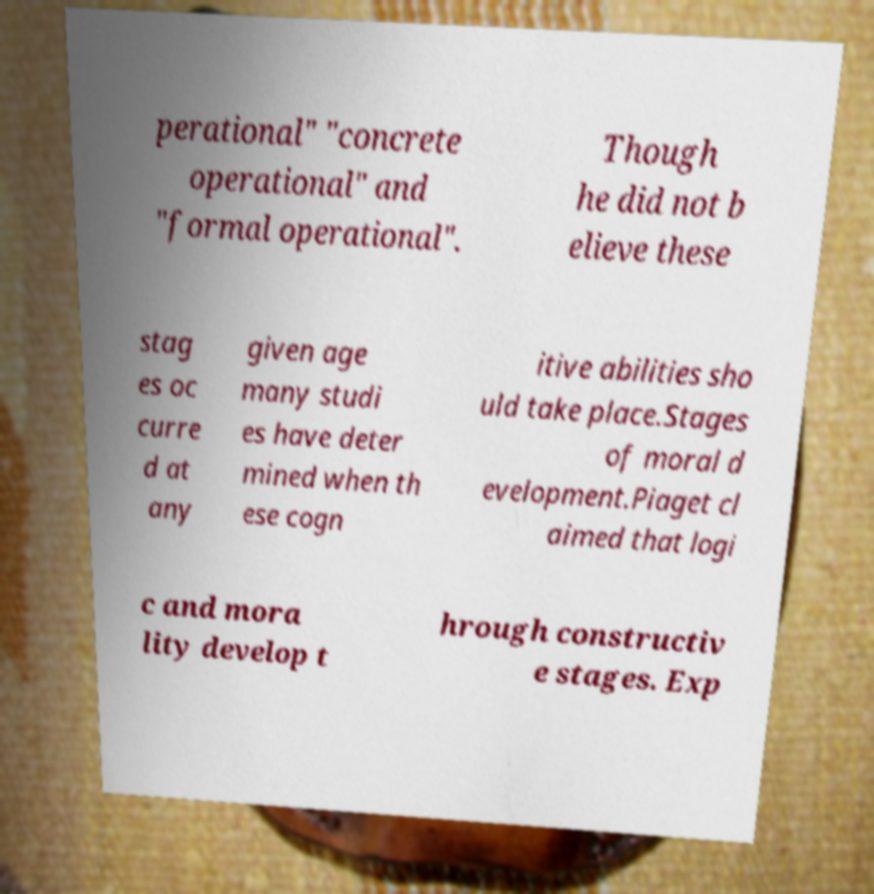What messages or text are displayed in this image? I need them in a readable, typed format. perational" "concrete operational" and "formal operational". Though he did not b elieve these stag es oc curre d at any given age many studi es have deter mined when th ese cogn itive abilities sho uld take place.Stages of moral d evelopment.Piaget cl aimed that logi c and mora lity develop t hrough constructiv e stages. Exp 